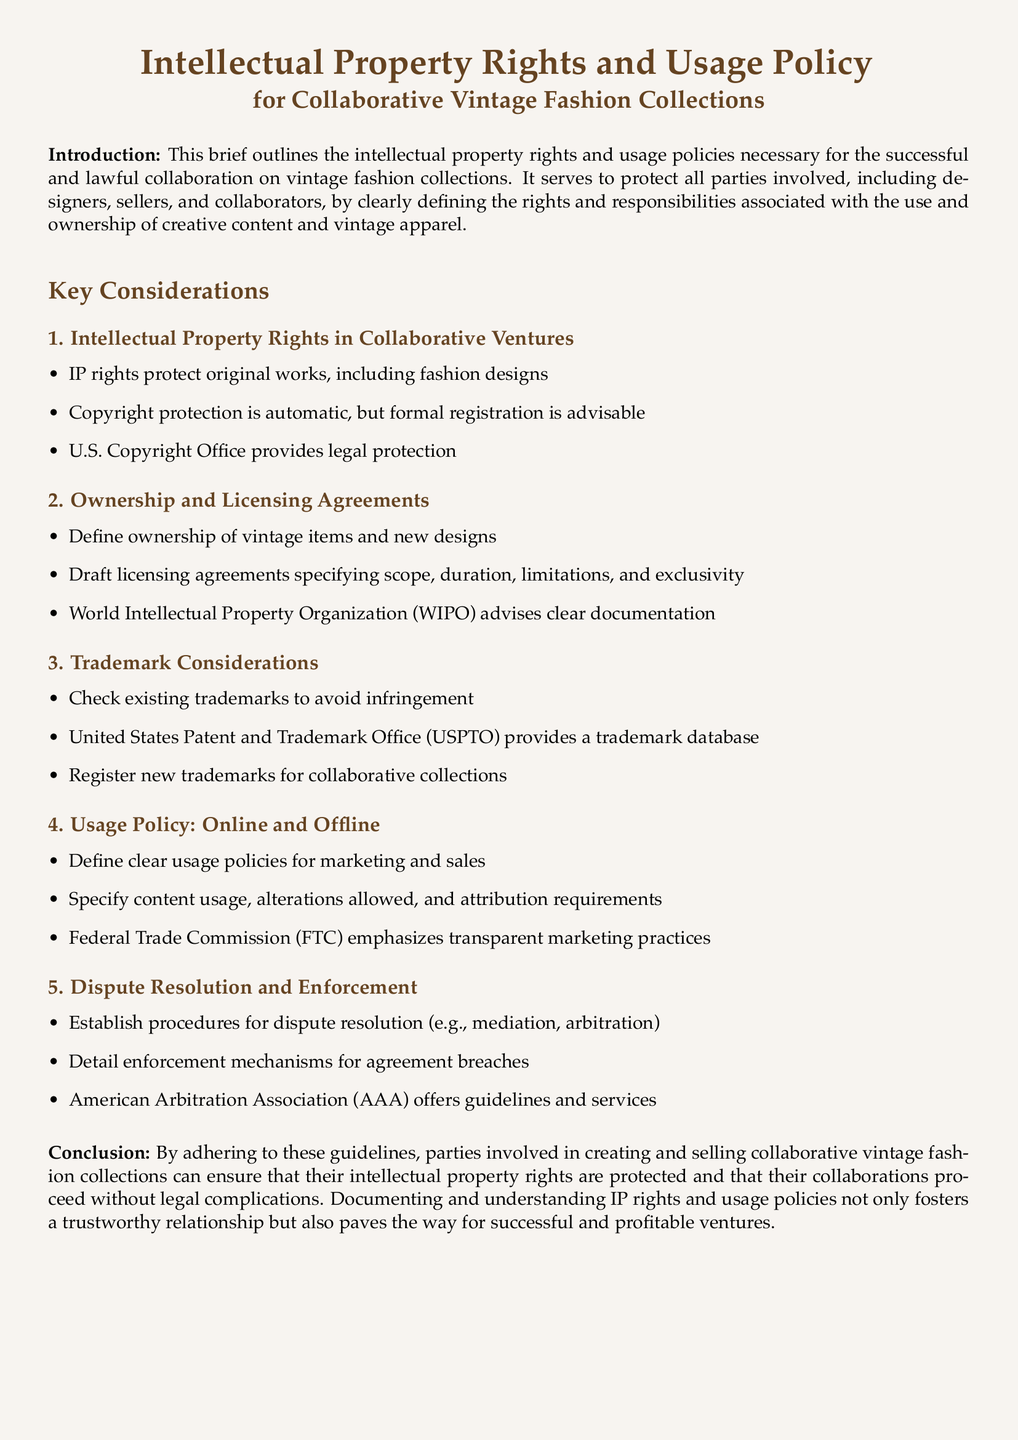What does IP stand for? IP refers to Intellectual Property, which encompasses rights safeguarding original works including fashion designs.
Answer: Intellectual Property What organization provides legal protection for copyrights? The document states that the U.S. Copyright Office provides legal protection for copyrights.
Answer: U.S. Copyright Office What is advised regarding trademarks? The document urges checking existing trademarks to avoid infringement and suggests registering new trademarks.
Answer: Register new trademarks What is one guideline for dispute resolution mentioned? The American Arbitration Association offers guidelines and services for establishing procedures for dispute resolution.
Answer: Mediation What type of policies must be defined for marketing and sales? The document specifies that clear usage policies must be defined for marketing and sales related to collaborative collections.
Answer: Usage policies What is a recommended action regarding copyright protection? The brief advises that while copyright protection is automatic, formal registration is advisable.
Answer: Formal registration What does the FTC emphasize in the context of marketing practices? The Federal Trade Commission emphasizes the importance of transparent marketing practices as part of the usage policy.
Answer: Transparent marketing What should licensing agreements specify? The document states that licensing agreements should specify scope, duration, limitations, and exclusivity.
Answer: Scope and duration What is the fundamental purpose of the document? The fundamental purpose is to outline intellectual property rights and usage policies for collaborative ventures in vintage fashion.
Answer: Protect parties involved 